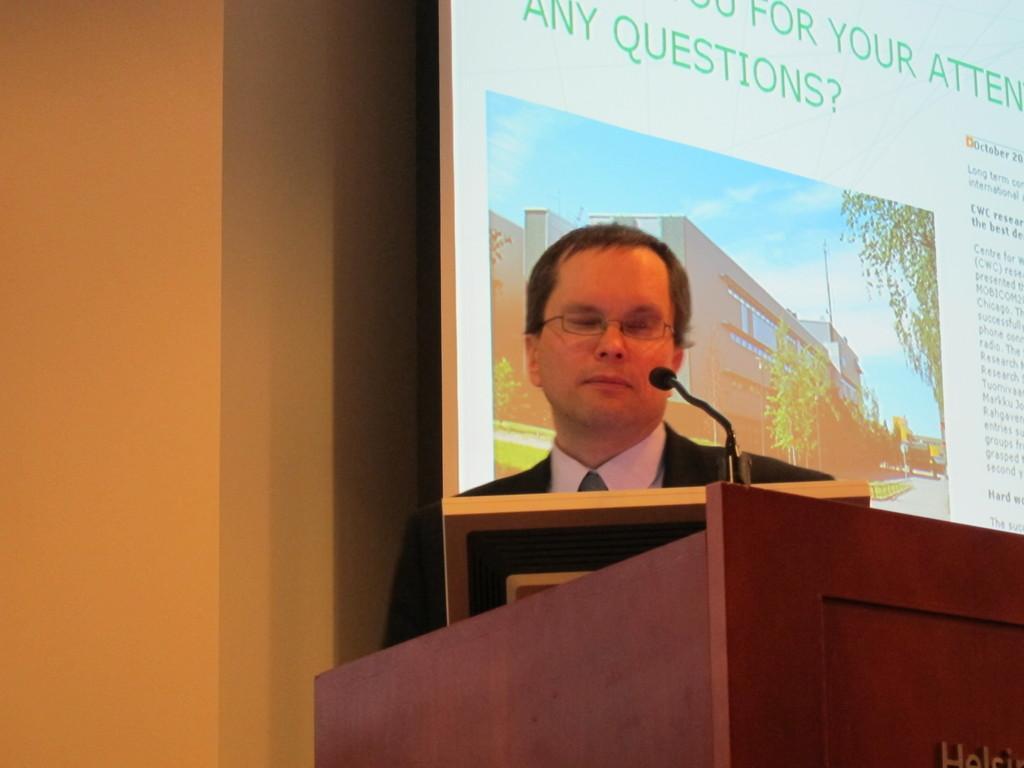Please provide a concise description of this image. There is a man wearing a specs. In front of him there is a podium with mic. Also there is a board. In the back there is a wall. On the wall there is a screen. On the screen there is an image and something is written. On the image there is a building, trees and sky. 